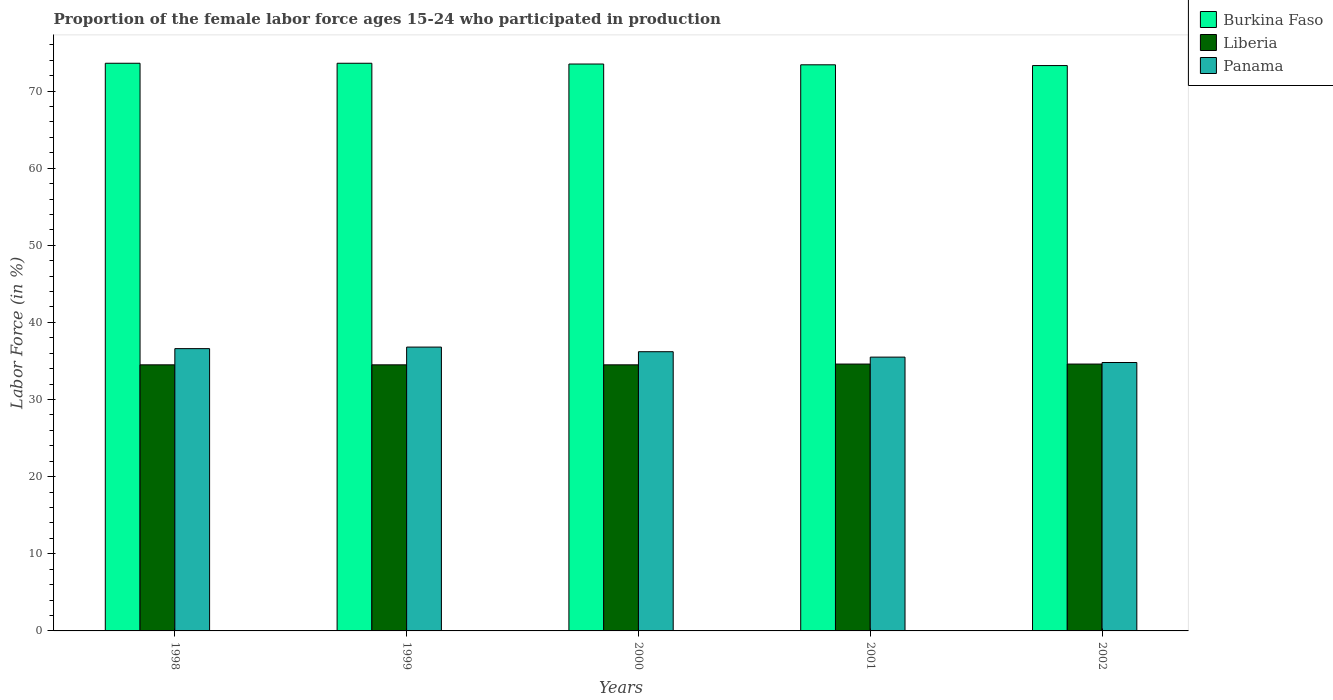How many bars are there on the 1st tick from the right?
Offer a terse response. 3. What is the proportion of the female labor force who participated in production in Burkina Faso in 1999?
Give a very brief answer. 73.6. Across all years, what is the maximum proportion of the female labor force who participated in production in Panama?
Make the answer very short. 36.8. Across all years, what is the minimum proportion of the female labor force who participated in production in Burkina Faso?
Your answer should be very brief. 73.3. In which year was the proportion of the female labor force who participated in production in Burkina Faso minimum?
Offer a terse response. 2002. What is the total proportion of the female labor force who participated in production in Burkina Faso in the graph?
Your answer should be very brief. 367.4. What is the difference between the proportion of the female labor force who participated in production in Liberia in 1998 and that in 2001?
Offer a very short reply. -0.1. What is the difference between the proportion of the female labor force who participated in production in Burkina Faso in 2001 and the proportion of the female labor force who participated in production in Panama in 2002?
Keep it short and to the point. 38.6. What is the average proportion of the female labor force who participated in production in Liberia per year?
Ensure brevity in your answer.  34.54. In the year 2001, what is the difference between the proportion of the female labor force who participated in production in Burkina Faso and proportion of the female labor force who participated in production in Liberia?
Make the answer very short. 38.8. What is the ratio of the proportion of the female labor force who participated in production in Burkina Faso in 1998 to that in 2002?
Your response must be concise. 1. Is the proportion of the female labor force who participated in production in Liberia in 1998 less than that in 2002?
Your answer should be compact. Yes. Is the difference between the proportion of the female labor force who participated in production in Burkina Faso in 1998 and 2000 greater than the difference between the proportion of the female labor force who participated in production in Liberia in 1998 and 2000?
Provide a succinct answer. Yes. What is the difference between the highest and the second highest proportion of the female labor force who participated in production in Liberia?
Offer a terse response. 0. What is the difference between the highest and the lowest proportion of the female labor force who participated in production in Burkina Faso?
Provide a short and direct response. 0.3. In how many years, is the proportion of the female labor force who participated in production in Burkina Faso greater than the average proportion of the female labor force who participated in production in Burkina Faso taken over all years?
Provide a short and direct response. 3. Is the sum of the proportion of the female labor force who participated in production in Panama in 1999 and 2000 greater than the maximum proportion of the female labor force who participated in production in Liberia across all years?
Give a very brief answer. Yes. What does the 1st bar from the left in 2000 represents?
Keep it short and to the point. Burkina Faso. What does the 3rd bar from the right in 1998 represents?
Offer a terse response. Burkina Faso. Is it the case that in every year, the sum of the proportion of the female labor force who participated in production in Panama and proportion of the female labor force who participated in production in Burkina Faso is greater than the proportion of the female labor force who participated in production in Liberia?
Make the answer very short. Yes. How many bars are there?
Provide a short and direct response. 15. Are all the bars in the graph horizontal?
Ensure brevity in your answer.  No. Are the values on the major ticks of Y-axis written in scientific E-notation?
Provide a succinct answer. No. Does the graph contain any zero values?
Your response must be concise. No. Does the graph contain grids?
Your response must be concise. No. How many legend labels are there?
Your answer should be compact. 3. How are the legend labels stacked?
Your answer should be compact. Vertical. What is the title of the graph?
Your response must be concise. Proportion of the female labor force ages 15-24 who participated in production. Does "Ireland" appear as one of the legend labels in the graph?
Provide a short and direct response. No. What is the label or title of the X-axis?
Give a very brief answer. Years. What is the Labor Force (in %) in Burkina Faso in 1998?
Your answer should be very brief. 73.6. What is the Labor Force (in %) in Liberia in 1998?
Provide a succinct answer. 34.5. What is the Labor Force (in %) of Panama in 1998?
Give a very brief answer. 36.6. What is the Labor Force (in %) in Burkina Faso in 1999?
Ensure brevity in your answer.  73.6. What is the Labor Force (in %) of Liberia in 1999?
Offer a very short reply. 34.5. What is the Labor Force (in %) of Panama in 1999?
Your answer should be compact. 36.8. What is the Labor Force (in %) of Burkina Faso in 2000?
Ensure brevity in your answer.  73.5. What is the Labor Force (in %) in Liberia in 2000?
Ensure brevity in your answer.  34.5. What is the Labor Force (in %) in Panama in 2000?
Offer a terse response. 36.2. What is the Labor Force (in %) in Burkina Faso in 2001?
Offer a terse response. 73.4. What is the Labor Force (in %) in Liberia in 2001?
Your response must be concise. 34.6. What is the Labor Force (in %) of Panama in 2001?
Keep it short and to the point. 35.5. What is the Labor Force (in %) of Burkina Faso in 2002?
Give a very brief answer. 73.3. What is the Labor Force (in %) in Liberia in 2002?
Keep it short and to the point. 34.6. What is the Labor Force (in %) of Panama in 2002?
Provide a short and direct response. 34.8. Across all years, what is the maximum Labor Force (in %) in Burkina Faso?
Your answer should be compact. 73.6. Across all years, what is the maximum Labor Force (in %) of Liberia?
Make the answer very short. 34.6. Across all years, what is the maximum Labor Force (in %) of Panama?
Offer a terse response. 36.8. Across all years, what is the minimum Labor Force (in %) of Burkina Faso?
Provide a succinct answer. 73.3. Across all years, what is the minimum Labor Force (in %) in Liberia?
Offer a very short reply. 34.5. Across all years, what is the minimum Labor Force (in %) of Panama?
Your answer should be compact. 34.8. What is the total Labor Force (in %) of Burkina Faso in the graph?
Offer a terse response. 367.4. What is the total Labor Force (in %) in Liberia in the graph?
Offer a very short reply. 172.7. What is the total Labor Force (in %) of Panama in the graph?
Keep it short and to the point. 179.9. What is the difference between the Labor Force (in %) in Burkina Faso in 1998 and that in 1999?
Make the answer very short. 0. What is the difference between the Labor Force (in %) of Liberia in 1998 and that in 1999?
Offer a very short reply. 0. What is the difference between the Labor Force (in %) in Burkina Faso in 1998 and that in 2000?
Offer a very short reply. 0.1. What is the difference between the Labor Force (in %) of Panama in 1998 and that in 2000?
Provide a short and direct response. 0.4. What is the difference between the Labor Force (in %) of Liberia in 1998 and that in 2001?
Give a very brief answer. -0.1. What is the difference between the Labor Force (in %) of Panama in 1998 and that in 2001?
Give a very brief answer. 1.1. What is the difference between the Labor Force (in %) of Burkina Faso in 1999 and that in 2001?
Offer a very short reply. 0.2. What is the difference between the Labor Force (in %) in Panama in 1999 and that in 2001?
Make the answer very short. 1.3. What is the difference between the Labor Force (in %) of Burkina Faso in 2000 and that in 2001?
Offer a very short reply. 0.1. What is the difference between the Labor Force (in %) in Liberia in 2000 and that in 2001?
Offer a very short reply. -0.1. What is the difference between the Labor Force (in %) of Burkina Faso in 2000 and that in 2002?
Offer a terse response. 0.2. What is the difference between the Labor Force (in %) in Liberia in 2001 and that in 2002?
Your answer should be very brief. 0. What is the difference between the Labor Force (in %) of Burkina Faso in 1998 and the Labor Force (in %) of Liberia in 1999?
Provide a succinct answer. 39.1. What is the difference between the Labor Force (in %) in Burkina Faso in 1998 and the Labor Force (in %) in Panama in 1999?
Provide a short and direct response. 36.8. What is the difference between the Labor Force (in %) of Burkina Faso in 1998 and the Labor Force (in %) of Liberia in 2000?
Keep it short and to the point. 39.1. What is the difference between the Labor Force (in %) of Burkina Faso in 1998 and the Labor Force (in %) of Panama in 2000?
Ensure brevity in your answer.  37.4. What is the difference between the Labor Force (in %) of Burkina Faso in 1998 and the Labor Force (in %) of Panama in 2001?
Your response must be concise. 38.1. What is the difference between the Labor Force (in %) in Liberia in 1998 and the Labor Force (in %) in Panama in 2001?
Provide a short and direct response. -1. What is the difference between the Labor Force (in %) in Burkina Faso in 1998 and the Labor Force (in %) in Panama in 2002?
Provide a succinct answer. 38.8. What is the difference between the Labor Force (in %) in Liberia in 1998 and the Labor Force (in %) in Panama in 2002?
Make the answer very short. -0.3. What is the difference between the Labor Force (in %) of Burkina Faso in 1999 and the Labor Force (in %) of Liberia in 2000?
Provide a succinct answer. 39.1. What is the difference between the Labor Force (in %) in Burkina Faso in 1999 and the Labor Force (in %) in Panama in 2000?
Keep it short and to the point. 37.4. What is the difference between the Labor Force (in %) in Liberia in 1999 and the Labor Force (in %) in Panama in 2000?
Offer a terse response. -1.7. What is the difference between the Labor Force (in %) of Burkina Faso in 1999 and the Labor Force (in %) of Panama in 2001?
Ensure brevity in your answer.  38.1. What is the difference between the Labor Force (in %) in Liberia in 1999 and the Labor Force (in %) in Panama in 2001?
Ensure brevity in your answer.  -1. What is the difference between the Labor Force (in %) in Burkina Faso in 1999 and the Labor Force (in %) in Panama in 2002?
Your answer should be compact. 38.8. What is the difference between the Labor Force (in %) of Liberia in 1999 and the Labor Force (in %) of Panama in 2002?
Ensure brevity in your answer.  -0.3. What is the difference between the Labor Force (in %) in Burkina Faso in 2000 and the Labor Force (in %) in Liberia in 2001?
Offer a terse response. 38.9. What is the difference between the Labor Force (in %) in Liberia in 2000 and the Labor Force (in %) in Panama in 2001?
Provide a succinct answer. -1. What is the difference between the Labor Force (in %) in Burkina Faso in 2000 and the Labor Force (in %) in Liberia in 2002?
Provide a short and direct response. 38.9. What is the difference between the Labor Force (in %) of Burkina Faso in 2000 and the Labor Force (in %) of Panama in 2002?
Offer a very short reply. 38.7. What is the difference between the Labor Force (in %) in Burkina Faso in 2001 and the Labor Force (in %) in Liberia in 2002?
Provide a short and direct response. 38.8. What is the difference between the Labor Force (in %) of Burkina Faso in 2001 and the Labor Force (in %) of Panama in 2002?
Your response must be concise. 38.6. What is the average Labor Force (in %) of Burkina Faso per year?
Offer a terse response. 73.48. What is the average Labor Force (in %) of Liberia per year?
Offer a very short reply. 34.54. What is the average Labor Force (in %) in Panama per year?
Your answer should be very brief. 35.98. In the year 1998, what is the difference between the Labor Force (in %) of Burkina Faso and Labor Force (in %) of Liberia?
Your answer should be compact. 39.1. In the year 1998, what is the difference between the Labor Force (in %) of Burkina Faso and Labor Force (in %) of Panama?
Ensure brevity in your answer.  37. In the year 1999, what is the difference between the Labor Force (in %) in Burkina Faso and Labor Force (in %) in Liberia?
Give a very brief answer. 39.1. In the year 1999, what is the difference between the Labor Force (in %) in Burkina Faso and Labor Force (in %) in Panama?
Offer a very short reply. 36.8. In the year 2000, what is the difference between the Labor Force (in %) in Burkina Faso and Labor Force (in %) in Liberia?
Offer a terse response. 39. In the year 2000, what is the difference between the Labor Force (in %) of Burkina Faso and Labor Force (in %) of Panama?
Your response must be concise. 37.3. In the year 2001, what is the difference between the Labor Force (in %) of Burkina Faso and Labor Force (in %) of Liberia?
Your answer should be very brief. 38.8. In the year 2001, what is the difference between the Labor Force (in %) in Burkina Faso and Labor Force (in %) in Panama?
Your answer should be compact. 37.9. In the year 2002, what is the difference between the Labor Force (in %) of Burkina Faso and Labor Force (in %) of Liberia?
Provide a succinct answer. 38.7. In the year 2002, what is the difference between the Labor Force (in %) of Burkina Faso and Labor Force (in %) of Panama?
Give a very brief answer. 38.5. What is the ratio of the Labor Force (in %) of Liberia in 1998 to that in 1999?
Offer a terse response. 1. What is the ratio of the Labor Force (in %) in Burkina Faso in 1998 to that in 2000?
Your response must be concise. 1. What is the ratio of the Labor Force (in %) of Panama in 1998 to that in 2000?
Offer a terse response. 1.01. What is the ratio of the Labor Force (in %) of Burkina Faso in 1998 to that in 2001?
Offer a terse response. 1. What is the ratio of the Labor Force (in %) in Liberia in 1998 to that in 2001?
Keep it short and to the point. 1. What is the ratio of the Labor Force (in %) in Panama in 1998 to that in 2001?
Provide a succinct answer. 1.03. What is the ratio of the Labor Force (in %) of Burkina Faso in 1998 to that in 2002?
Offer a very short reply. 1. What is the ratio of the Labor Force (in %) in Panama in 1998 to that in 2002?
Give a very brief answer. 1.05. What is the ratio of the Labor Force (in %) in Panama in 1999 to that in 2000?
Provide a succinct answer. 1.02. What is the ratio of the Labor Force (in %) in Burkina Faso in 1999 to that in 2001?
Provide a short and direct response. 1. What is the ratio of the Labor Force (in %) in Liberia in 1999 to that in 2001?
Provide a succinct answer. 1. What is the ratio of the Labor Force (in %) of Panama in 1999 to that in 2001?
Provide a short and direct response. 1.04. What is the ratio of the Labor Force (in %) of Liberia in 1999 to that in 2002?
Your response must be concise. 1. What is the ratio of the Labor Force (in %) of Panama in 1999 to that in 2002?
Your answer should be compact. 1.06. What is the ratio of the Labor Force (in %) in Panama in 2000 to that in 2001?
Keep it short and to the point. 1.02. What is the ratio of the Labor Force (in %) of Liberia in 2000 to that in 2002?
Offer a very short reply. 1. What is the ratio of the Labor Force (in %) in Panama in 2000 to that in 2002?
Make the answer very short. 1.04. What is the ratio of the Labor Force (in %) in Burkina Faso in 2001 to that in 2002?
Offer a very short reply. 1. What is the ratio of the Labor Force (in %) of Panama in 2001 to that in 2002?
Provide a short and direct response. 1.02. What is the difference between the highest and the second highest Labor Force (in %) of Burkina Faso?
Provide a succinct answer. 0. What is the difference between the highest and the lowest Labor Force (in %) in Liberia?
Your response must be concise. 0.1. 